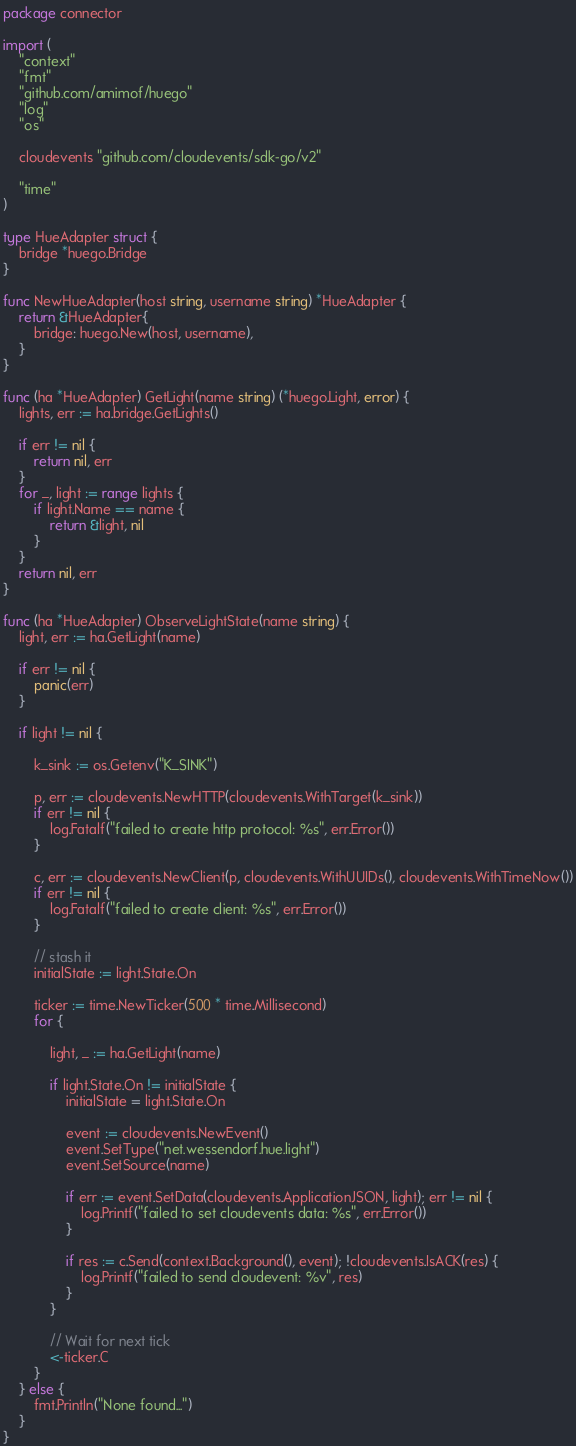<code> <loc_0><loc_0><loc_500><loc_500><_Go_>package connector

import (
	"context"
	"fmt"
	"github.com/amimof/huego"
	"log"
	"os"

	cloudevents "github.com/cloudevents/sdk-go/v2"

	"time"
)

type HueAdapter struct {
	bridge *huego.Bridge
}

func NewHueAdapter(host string, username string) *HueAdapter {
	return &HueAdapter{
		bridge: huego.New(host, username),
	}
}

func (ha *HueAdapter) GetLight(name string) (*huego.Light, error) {
	lights, err := ha.bridge.GetLights()

	if err != nil {
		return nil, err
	}
	for _, light := range lights {
		if light.Name == name {
			return &light, nil
		}
	}
	return nil, err
}

func (ha *HueAdapter) ObserveLightState(name string) {
	light, err := ha.GetLight(name)

	if err != nil {
		panic(err)
	}

	if light != nil {

		k_sink := os.Getenv("K_SINK")

		p, err := cloudevents.NewHTTP(cloudevents.WithTarget(k_sink))
		if err != nil {
			log.Fatalf("failed to create http protocol: %s", err.Error())
		}

		c, err := cloudevents.NewClient(p, cloudevents.WithUUIDs(), cloudevents.WithTimeNow())
		if err != nil {
			log.Fatalf("failed to create client: %s", err.Error())
		}

		// stash it
		initialState := light.State.On

		ticker := time.NewTicker(500 * time.Millisecond)
		for {

			light, _ := ha.GetLight(name)

			if light.State.On != initialState {
				initialState = light.State.On

				event := cloudevents.NewEvent()
				event.SetType("net.wessendorf.hue.light")
				event.SetSource(name)

				if err := event.SetData(cloudevents.ApplicationJSON, light); err != nil {
					log.Printf("failed to set cloudevents data: %s", err.Error())
				}

				if res := c.Send(context.Background(), event); !cloudevents.IsACK(res) {
					log.Printf("failed to send cloudevent: %v", res)
				}
			}

			// Wait for next tick
			<-ticker.C
		}
	} else {
		fmt.Println("None found...")
	}
}</code> 